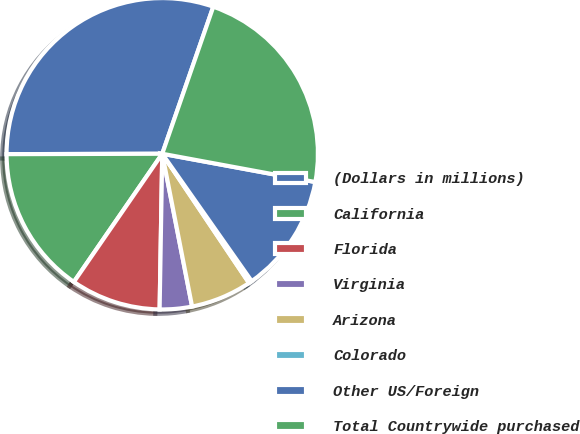Convert chart. <chart><loc_0><loc_0><loc_500><loc_500><pie_chart><fcel>(Dollars in millions)<fcel>California<fcel>Florida<fcel>Virginia<fcel>Arizona<fcel>Colorado<fcel>Other US/Foreign<fcel>Total Countrywide purchased<nl><fcel>30.36%<fcel>15.35%<fcel>9.34%<fcel>3.34%<fcel>6.34%<fcel>0.33%<fcel>12.35%<fcel>22.59%<nl></chart> 